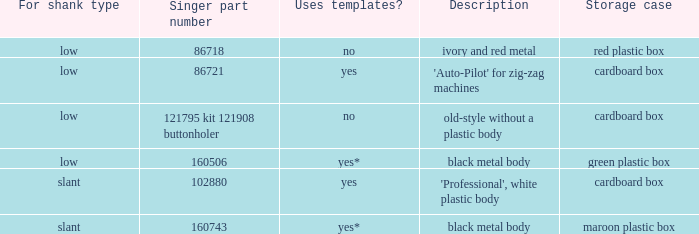What is the vocalist component number for the buttonholer with a green plastic container as its storage case? 160506.0. 